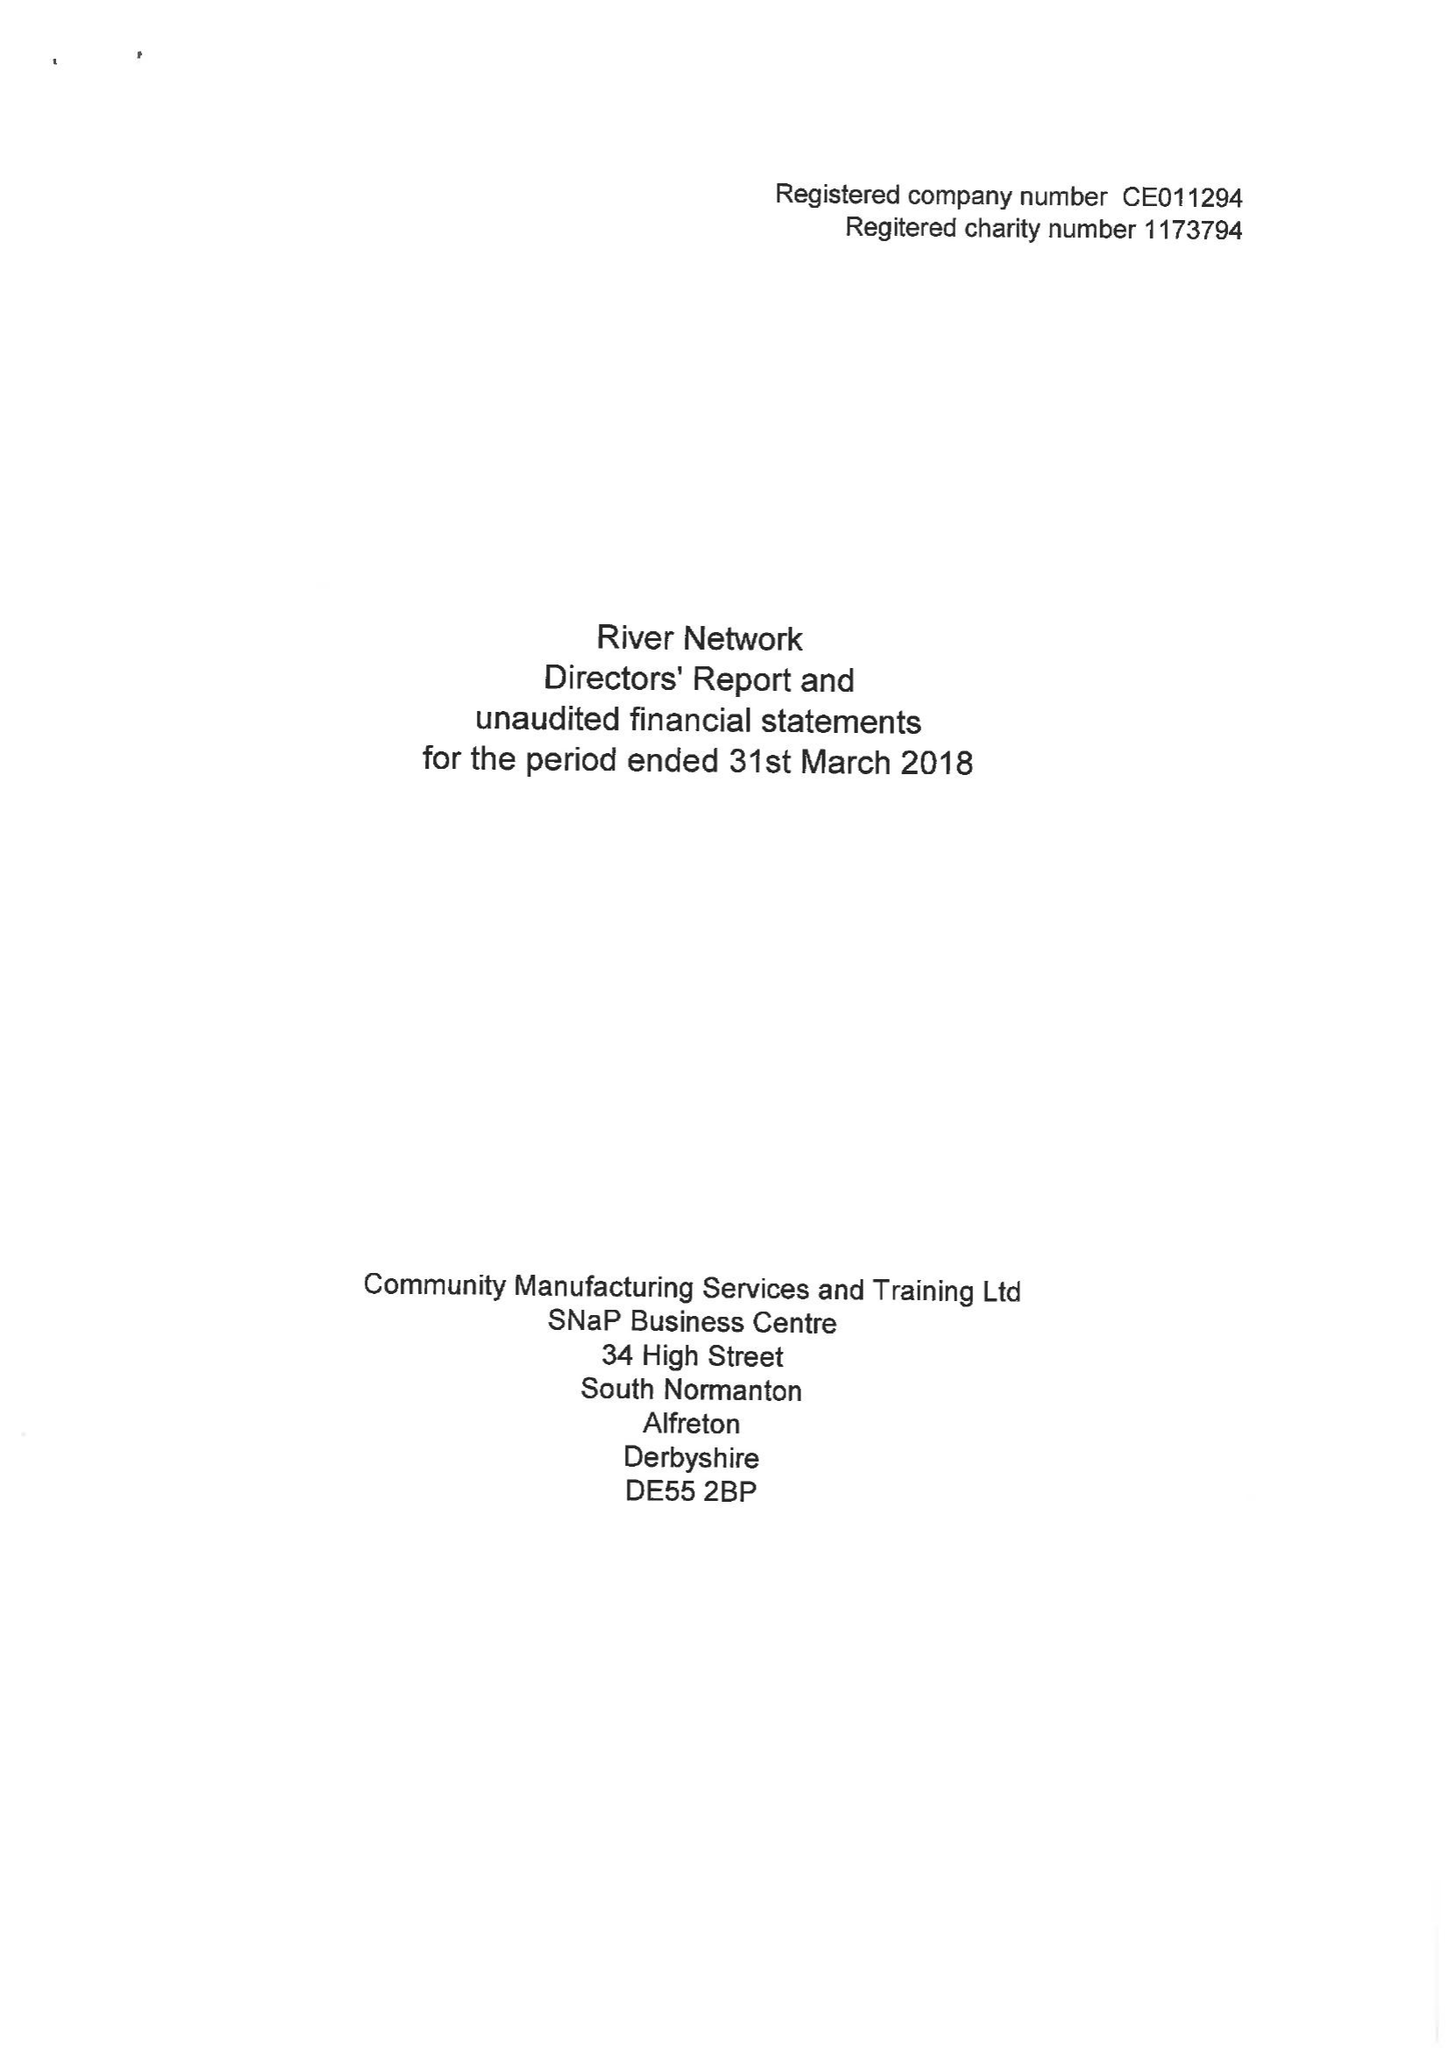What is the value for the address__post_town?
Answer the question using a single word or phrase. None 